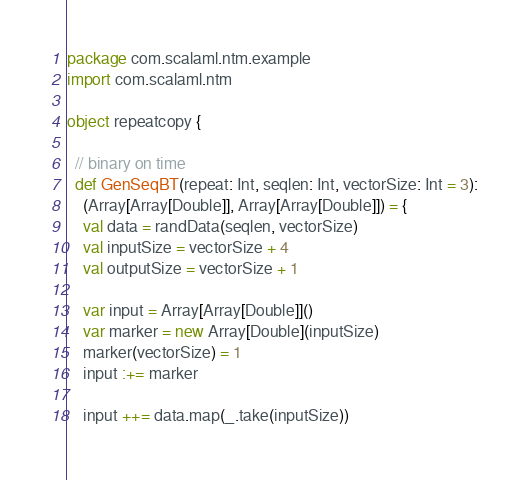<code> <loc_0><loc_0><loc_500><loc_500><_Scala_>package com.scalaml.ntm.example
import com.scalaml.ntm

object repeatcopy {

  // binary on time
  def GenSeqBT(repeat: Int, seqlen: Int, vectorSize: Int = 3):
    (Array[Array[Double]], Array[Array[Double]]) = {
    val data = randData(seqlen, vectorSize)
    val inputSize = vectorSize + 4
    val outputSize = vectorSize + 1

    var input = Array[Array[Double]]()
    var marker = new Array[Double](inputSize)
    marker(vectorSize) = 1
    input :+= marker

    input ++= data.map(_.take(inputSize))
</code> 